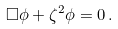<formula> <loc_0><loc_0><loc_500><loc_500>\Box \phi + \zeta ^ { 2 } \phi = 0 \, .</formula> 